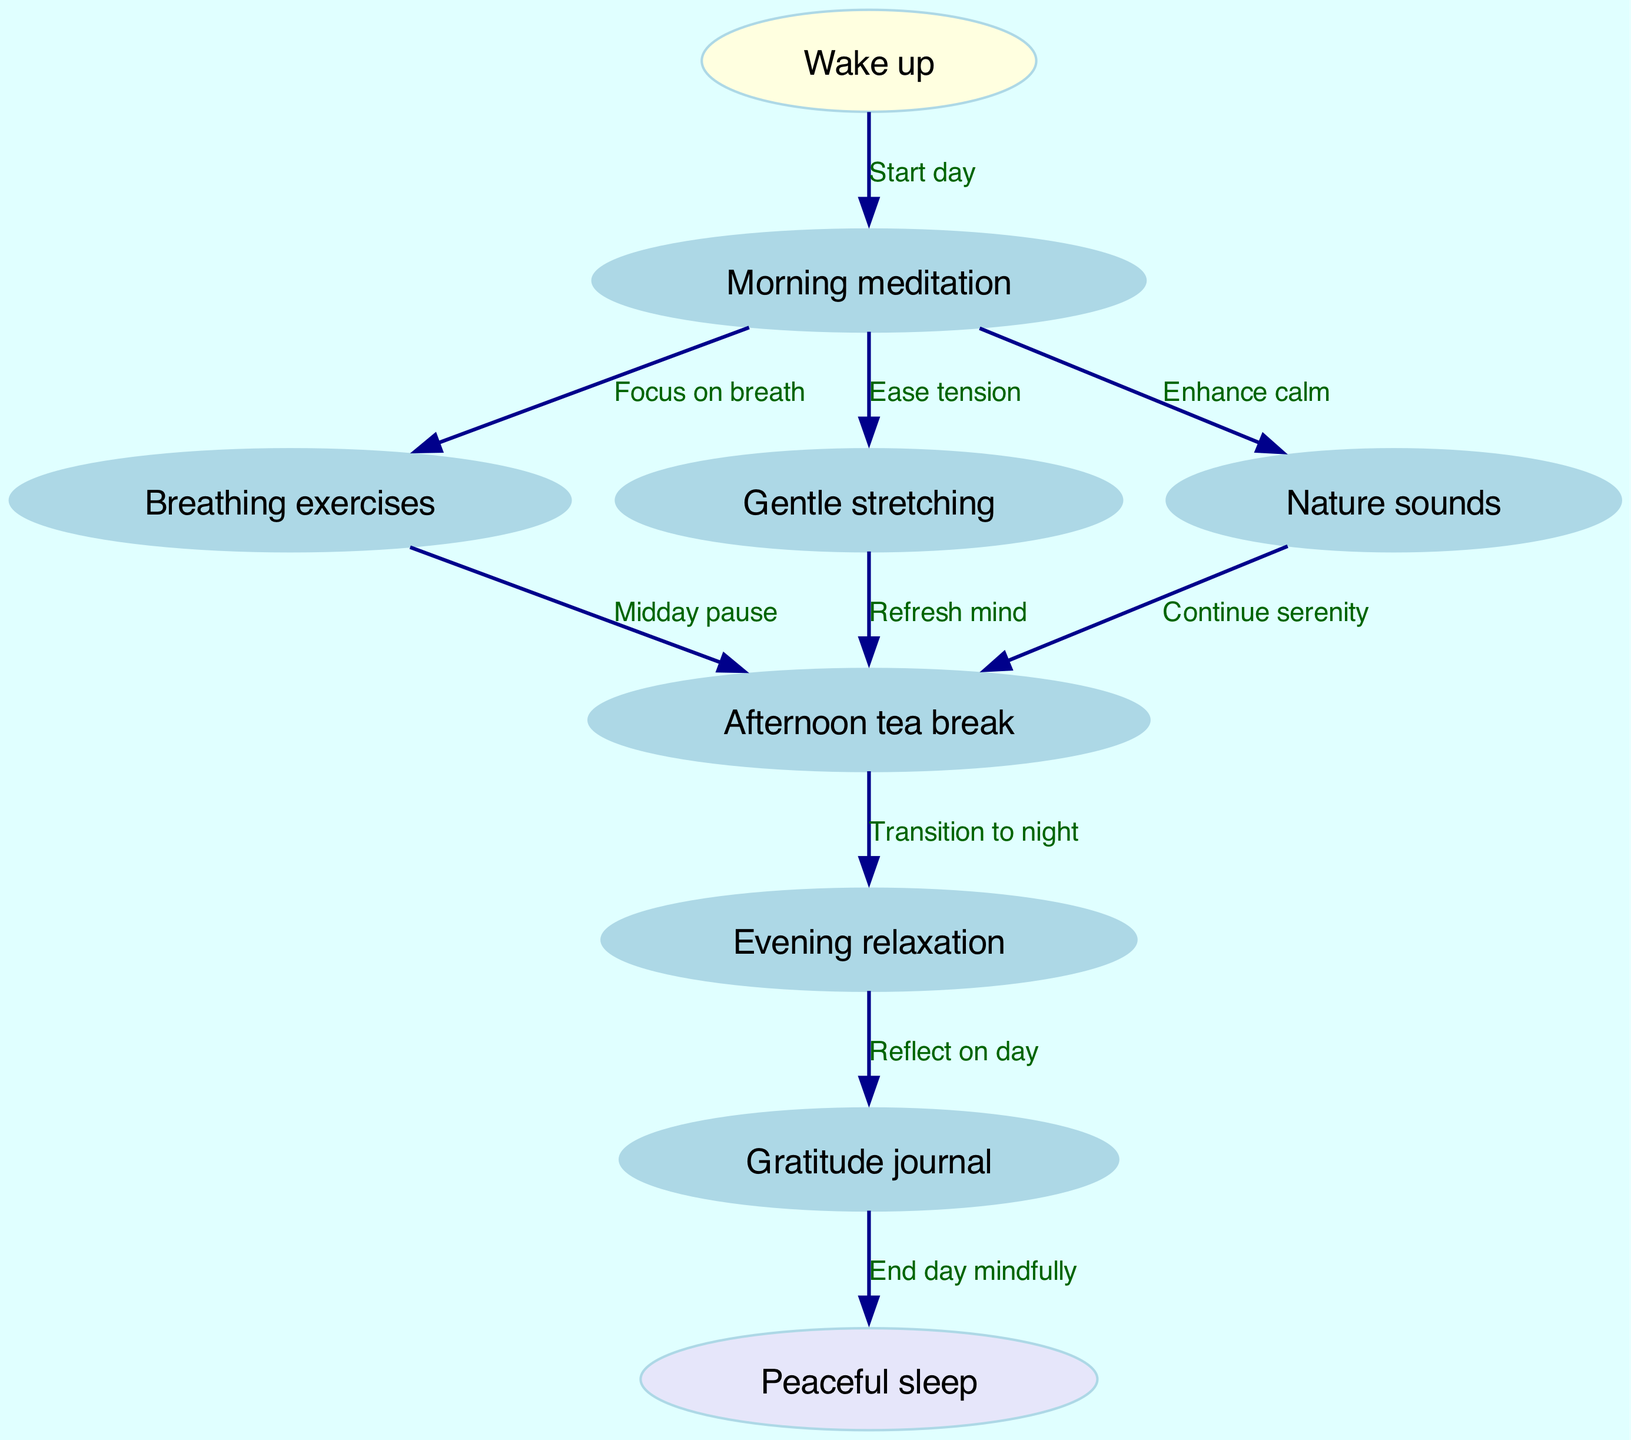What is the starting point of the daily meditation routine? The starting point is indicated as "Wake up" in the diagram. It is the first node from which the daily routine begins.
Answer: Wake up How many relaxation techniques branch from the morning meditation? The diagram shows three branches (Breathing exercises, Gentle stretching, Nature sounds) stemming from the "Morning meditation" node, indicating three techniques.
Answer: 3 What activity follows "Afternoon tea break" in the routine? The diagram shows that after "Afternoon tea break," the next activity is "Evening relaxation," which is connected by an edge labeled "Transition to night."
Answer: Evening relaxation Which activity reflects on the day before sleep? The edge from "Evening relaxation" to "Gratitude journal" indicates that the "Gratitude journal" is the activity used to reflect on the day before transitioning to "Peaceful sleep."
Answer: Gratitude journal What is the final stage of the daily meditation routine? According to the diagram, "Peaceful sleep" is indicated as the last node, completing the daily meditation routine.
Answer: Peaceful sleep How many total nodes are present in the diagram? By counting each distinct activity listed in the nodes, there are a total of nine nodes represented in the diagram.
Answer: 9 Which relaxation technique is primarily focused on easing physical tension? The diagram highlights "Gentle stretching" as the technique specifically aimed at easing physical tension, branching from "Morning meditation."
Answer: Gentle stretching What transition occurs after "Breathing exercises"? The diagram illustrates that after "Breathing exercises," the routine transitions to "Afternoon tea break," demonstrating a clear connection and pause.
Answer: Afternoon tea break What is the connection between "Nature sounds" and "Afternoon tea break"? The edge between "Nature sounds" and "Afternoon tea break" is indicated with the label "Continue serenity," showing a direct pathway from one activity to another.
Answer: Continue serenity 